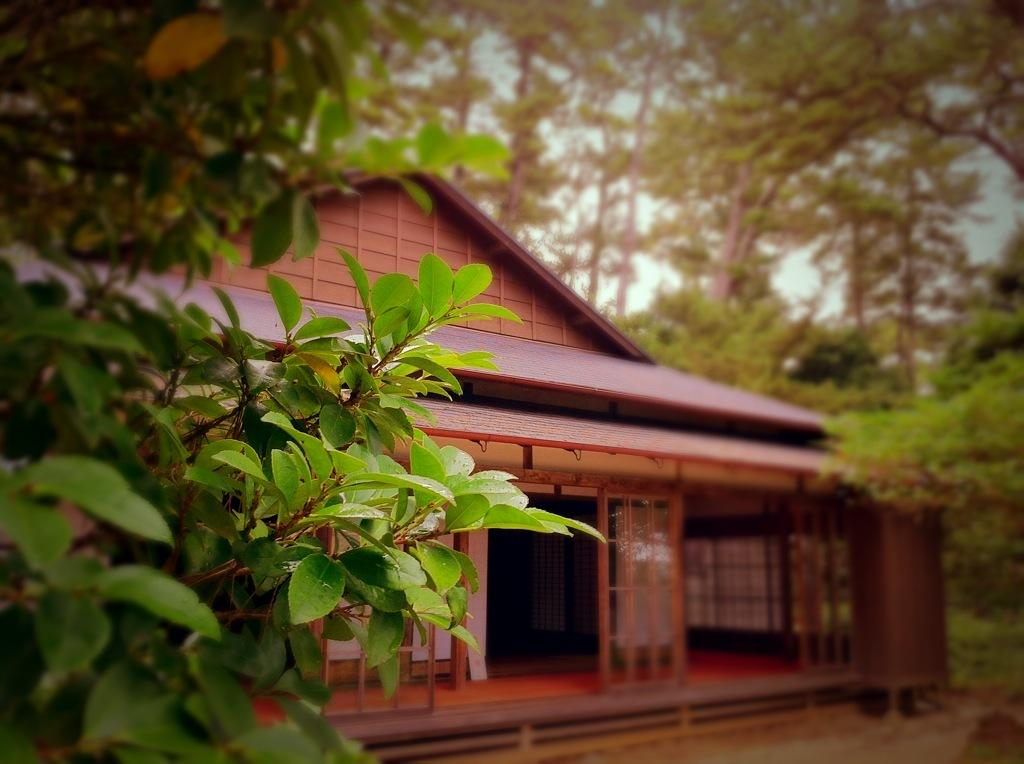What type of structure is present in the image? There is a house in the image. What can be seen behind the house? There are trees behind the house in the image. What part of the natural environment is visible in the image? The sky is visible in the image. What type of ship can be seen sailing in the scene? There is no ship present in the image; it features a house with trees behind it and the sky visible. 